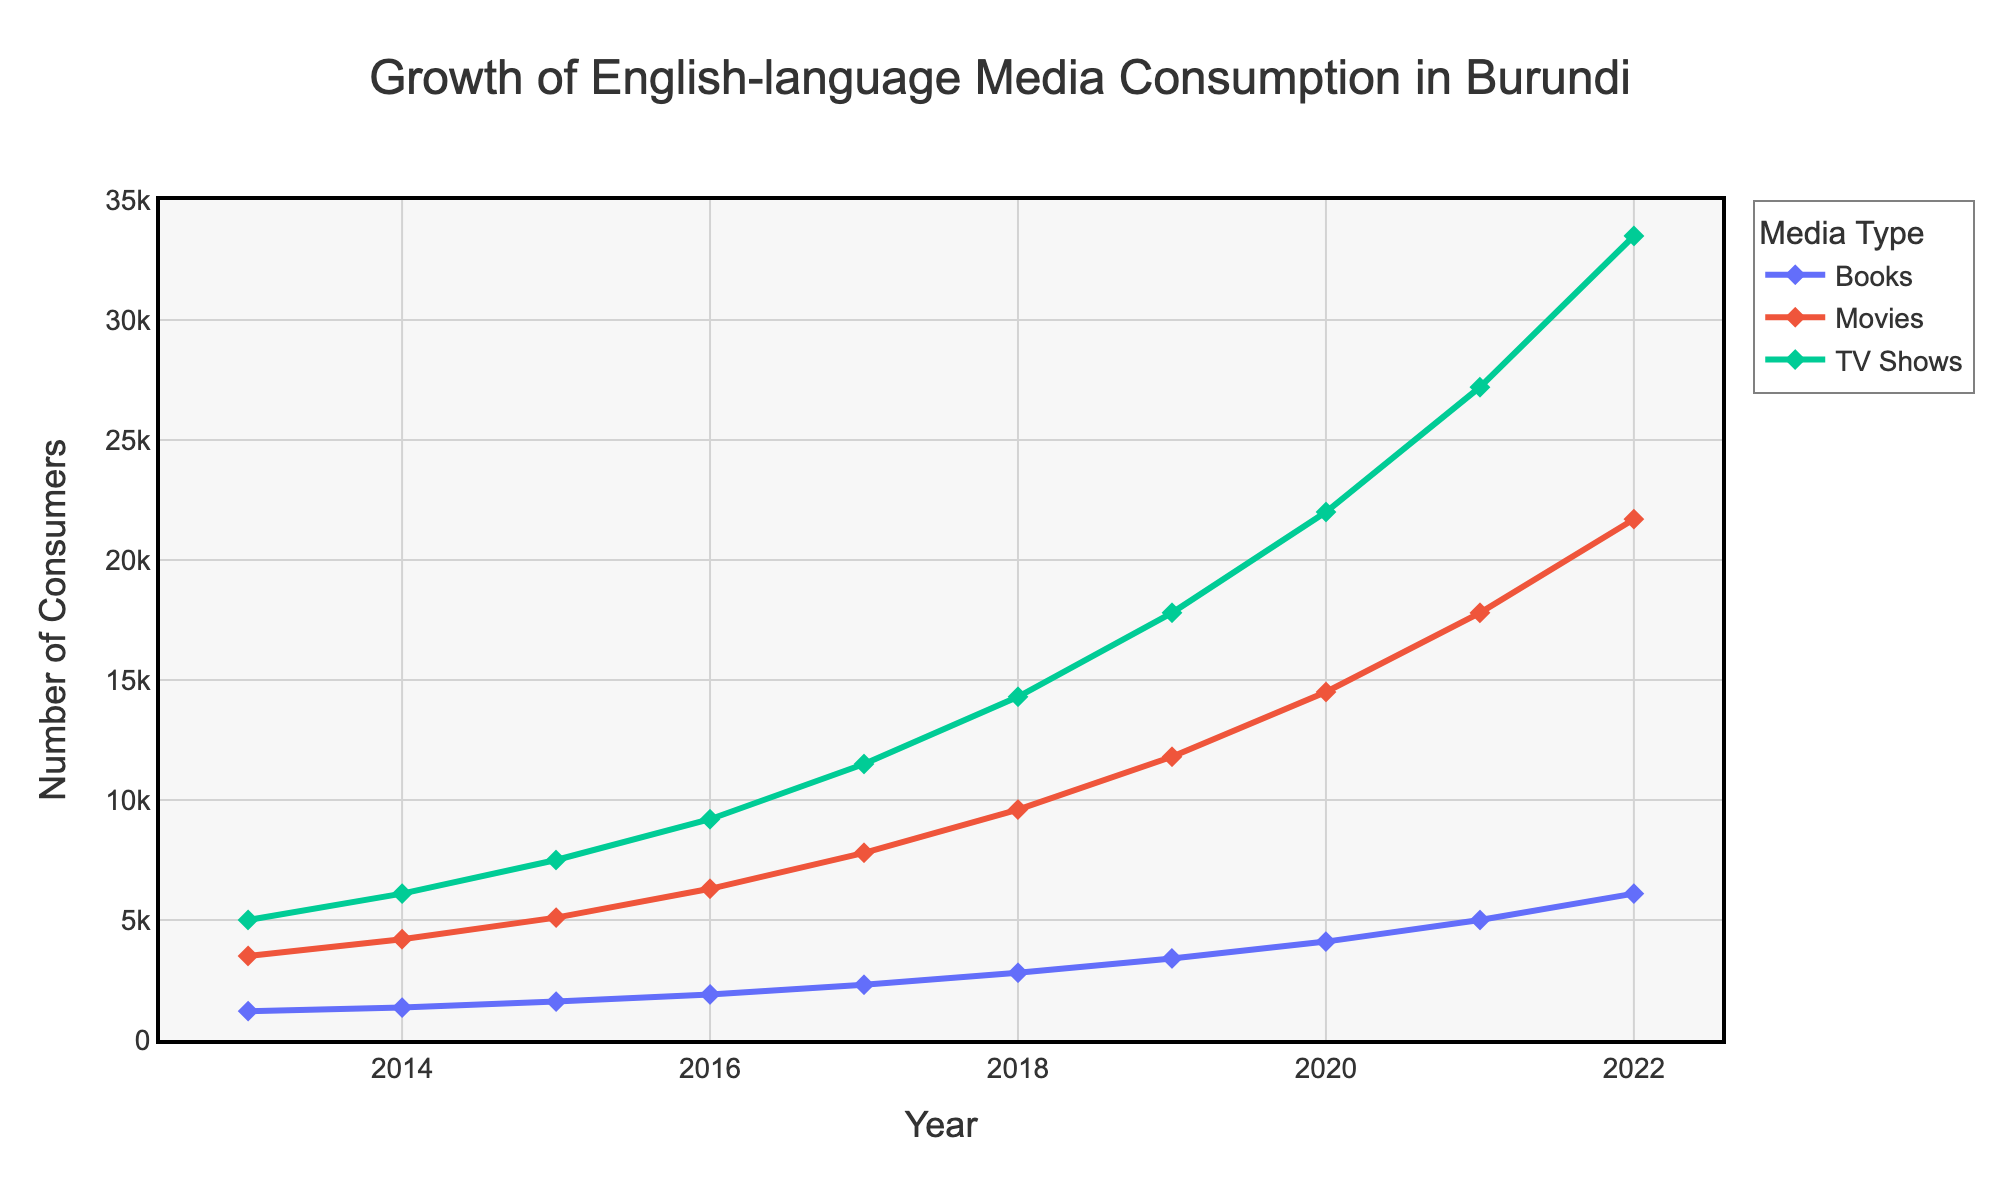Which medium showed the highest number of consumers in 2022? By looking at the endpoints of each line at the year 2022, you can see that TV Shows have the highest point, which indicates that TV Shows had the highest number of consumers.
Answer: TV Shows How much did book consumption increase from 2013 to 2016? The number of book consumers in 2013 was 1200, and by 2016 it had grown to 1900. The increase can be calculated by subtracting 1200 from 1900.
Answer: 700 Compare the growth rates of Movies and TV Shows between 2017 and 2020. Which grew more? First, find the number of consumers for both Movies and TV Shows in 2017 and 2020. For Movies: 7800 in 2017 and 14500 in 2020, the growth is 14500 - 7800 = 6700. For TV Shows: 11500 in 2017 and 22000 in 2020, the growth is 22000 - 11500 = 10500. Comparing the two, TV Shows grew more.
Answer: TV Shows What is the total increase in consumers for all three media from 2014 to 2022? Add the consumers for each medium in 2014 and 2022. In 2014: Books = 1350, Movies = 4200, TV Shows = 6100. Total for 2014 is 1350 + 4200 + 6100 = 11650. In 2022: Books = 6100, Movies = 21700, TV Shows = 33500. Total for 2022 is 6100 + 21700 + 33500 = 61300. The total increase is 61300 - 11650.
Answer: 49650 Which year saw the smallest increase in book consumption? Calculate the year-over-year increase for books: 2014-2013 = 150, 2015-2014 = 250, 2016-2015 = 300, 2017-2016 = 400, 2018-2017 = 500, 2019-2018 = 600, 2020-2019 = 700, 2021-2020 = 900, 2022-2021 = 1100. The smallest increase is from 2013 to 2014.
Answer: 2014 How did the number of TV show consumers change from 2019 to 2021? The number of TV show consumers in 2019 was 17800 and in 2021 it was 27200. The change is 27200 - 17800.
Answer: 9400 By how much did movie consumption surpass book consumption in 2020? In 2020, movie consumption was 14500 and book consumption was 4100. The difference is 14500 - 4100.
Answer: 10400 What was the average annual number of movie consumers between 2013 and 2018? Sum the number of movie consumers from 2013 to 2018 (3500 + 4200 + 5100 + 6300 + 7800 + 9600 = 36500), then divide by the number of years (6).
Answer: 6083.33 In which year did TV Shows surpass 20000 consumers? Checking the consumer numbers for each year, TV Shows first have over 20000 consumers in 2020.
Answer: 2020 Which medium had the most significant yearly growth between 2021 and 2022? Calculate the yearly growth for each medium from 2021 to 2022: Books (6100-5000=1100), Movies (21700-17800=3900), TV Shows (33500-27200=6300). TV Shows had the most significant growth.
Answer: TV Shows 